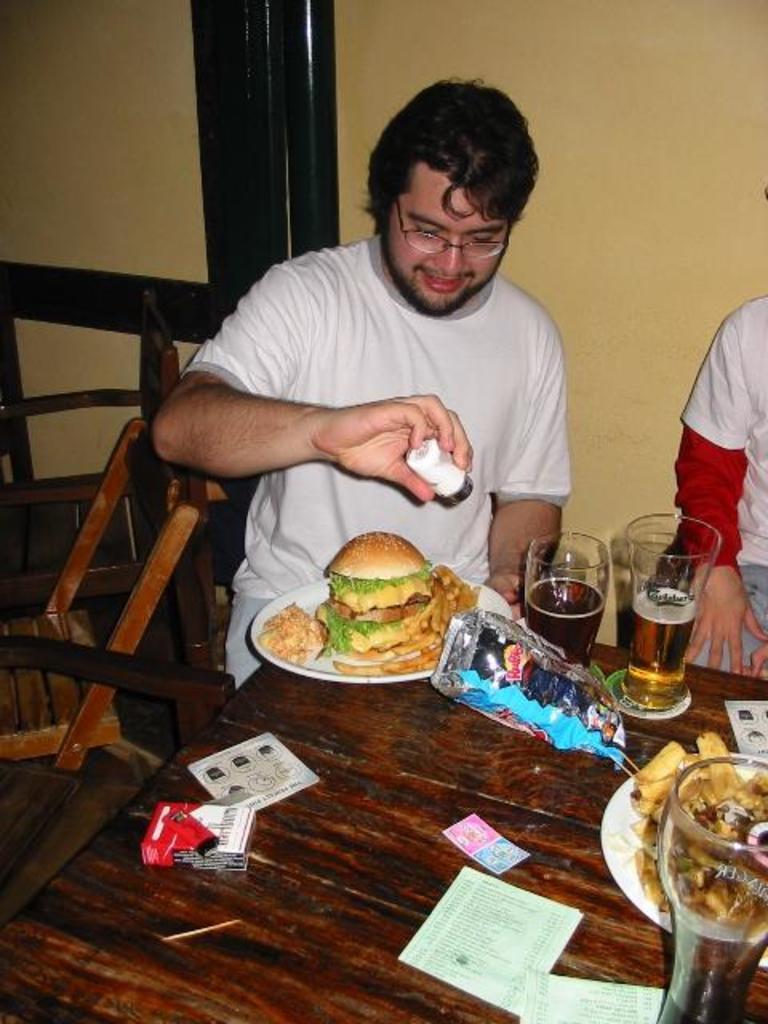Describe this image in one or two sentences. It the picture it looks like a party, there is a table two persons are sitting in front of the table there are alcohol glasses, some fry items , a burger, few other papers on the table a person who is wearing white color shirt is holding salt or pepper bottle in his hand in the background there is a cream color wall. 